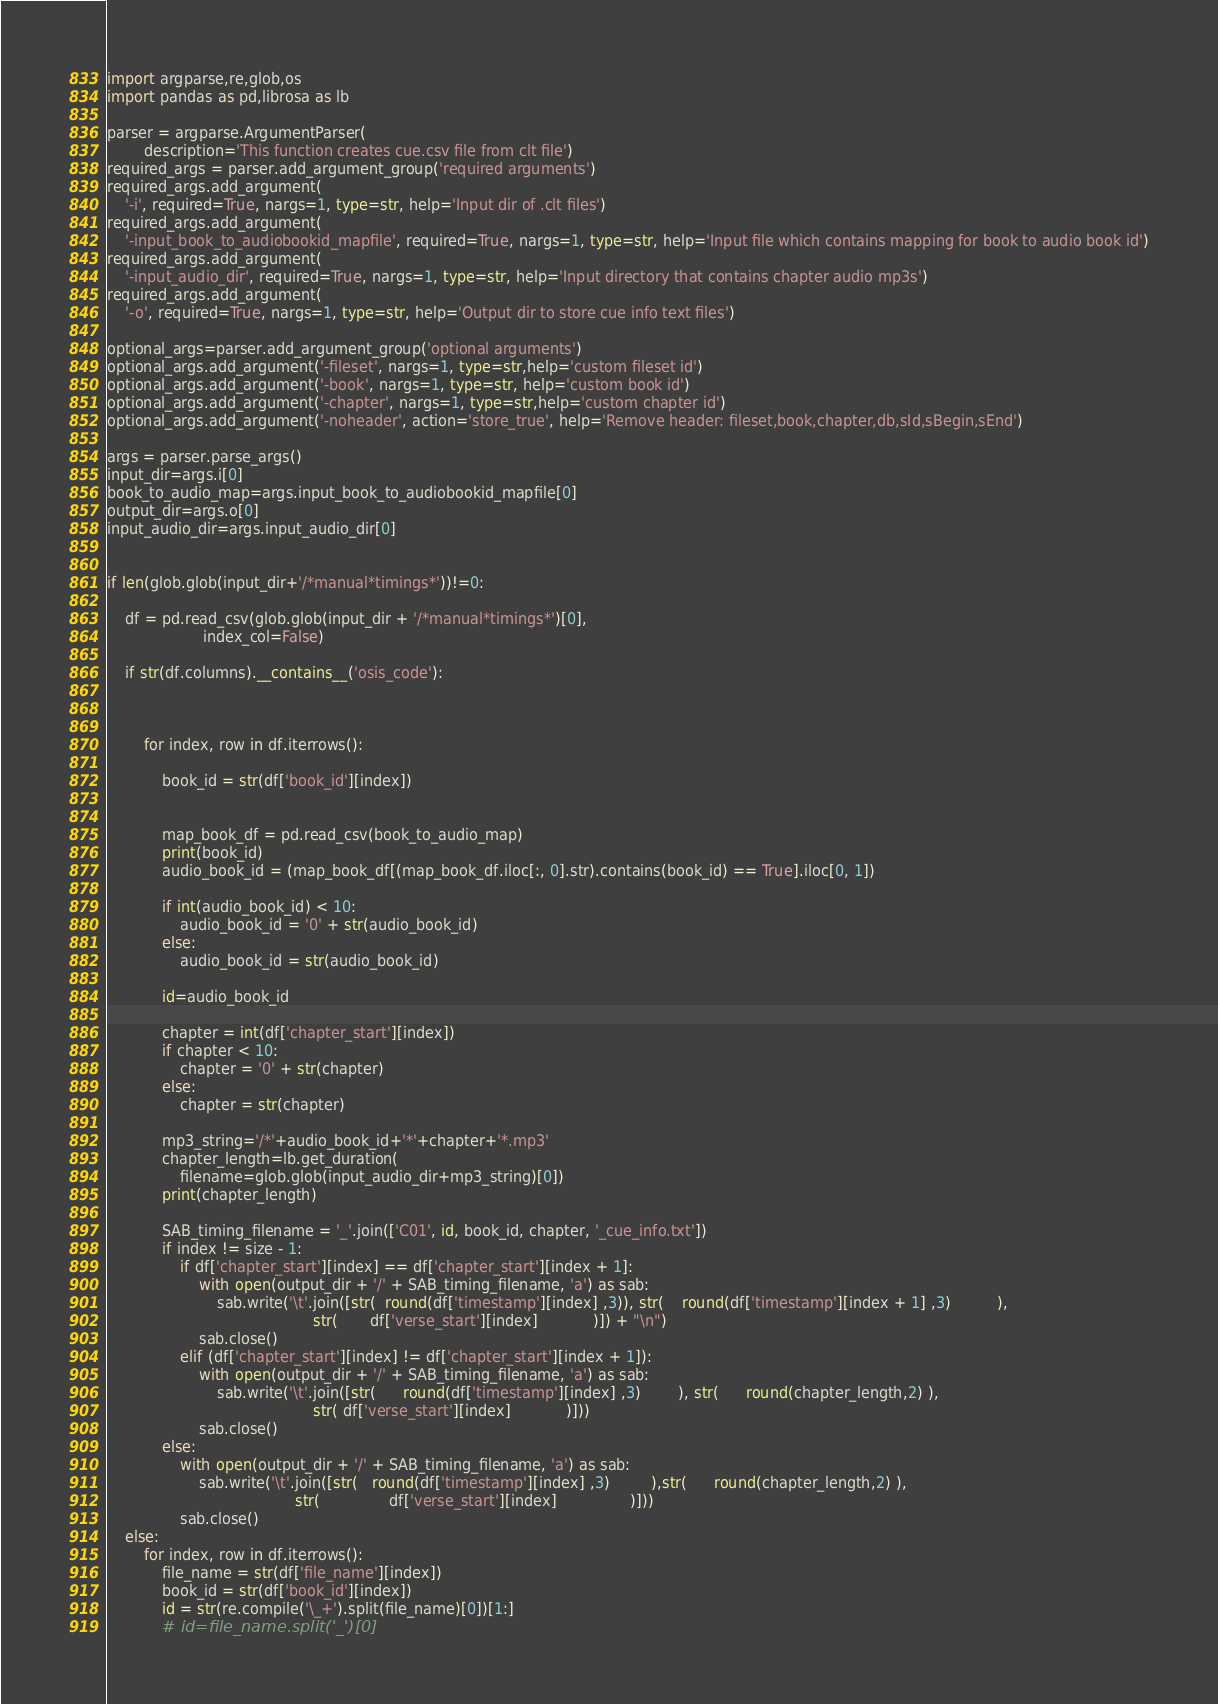<code> <loc_0><loc_0><loc_500><loc_500><_Python_>import argparse,re,glob,os
import pandas as pd,librosa as lb

parser = argparse.ArgumentParser(
        description='This function creates cue.csv file from clt file')
required_args = parser.add_argument_group('required arguments')
required_args.add_argument(
    '-i', required=True, nargs=1, type=str, help='Input dir of .clt files')
required_args.add_argument(
    '-input_book_to_audiobookid_mapfile', required=True, nargs=1, type=str, help='Input file which contains mapping for book to audio book id')
required_args.add_argument(
    '-input_audio_dir', required=True, nargs=1, type=str, help='Input directory that contains chapter audio mp3s')
required_args.add_argument(
    '-o', required=True, nargs=1, type=str, help='Output dir to store cue info text files')

optional_args=parser.add_argument_group('optional arguments')
optional_args.add_argument('-fileset', nargs=1, type=str,help='custom fileset id')
optional_args.add_argument('-book', nargs=1, type=str, help='custom book id')
optional_args.add_argument('-chapter', nargs=1, type=str,help='custom chapter id')
optional_args.add_argument('-noheader', action='store_true', help='Remove header: fileset,book,chapter,db,sId,sBegin,sEnd')

args = parser.parse_args()
input_dir=args.i[0]
book_to_audio_map=args.input_book_to_audiobookid_mapfile[0]
output_dir=args.o[0]
input_audio_dir=args.input_audio_dir[0]


if len(glob.glob(input_dir+'/*manual*timings*'))!=0:

    df = pd.read_csv(glob.glob(input_dir + '/*manual*timings*')[0],
                     index_col=False)

    if str(df.columns).__contains__('osis_code'):



        for index, row in df.iterrows():

            book_id = str(df['book_id'][index])


            map_book_df = pd.read_csv(book_to_audio_map)
            print(book_id)
            audio_book_id = (map_book_df[(map_book_df.iloc[:, 0].str).contains(book_id) == True].iloc[0, 1])

            if int(audio_book_id) < 10:
                audio_book_id = '0' + str(audio_book_id)
            else:
                audio_book_id = str(audio_book_id)

            id=audio_book_id

            chapter = int(df['chapter_start'][index])
            if chapter < 10:
                chapter = '0' + str(chapter)
            else:
                chapter = str(chapter)

            mp3_string='/*'+audio_book_id+'*'+chapter+'*.mp3'
            chapter_length=lb.get_duration(
                filename=glob.glob(input_audio_dir+mp3_string)[0])
            print(chapter_length)

            SAB_timing_filename = '_'.join(['C01', id, book_id, chapter, '_cue_info.txt'])
            if index != size - 1:
                if df['chapter_start'][index] == df['chapter_start'][index + 1]:
                    with open(output_dir + '/' + SAB_timing_filename, 'a') as sab:
                        sab.write('\t'.join([str(  round(df['timestamp'][index] ,3)), str(    round(df['timestamp'][index + 1] ,3)          ),
                                             str(       df['verse_start'][index]            )]) + "\n")
                    sab.close()
                elif (df['chapter_start'][index] != df['chapter_start'][index + 1]):
                    with open(output_dir + '/' + SAB_timing_filename, 'a') as sab:
                        sab.write('\t'.join([str(      round(df['timestamp'][index] ,3)        ), str(      round(chapter_length,2) ),
                                             str( df['verse_start'][index]            )]))
                    sab.close()
            else:
                with open(output_dir + '/' + SAB_timing_filename, 'a') as sab:
                    sab.write('\t'.join([str(   round(df['timestamp'][index] ,3)         ),str(      round(chapter_length,2) ),
                                         str(               df['verse_start'][index]                )]))
                sab.close()
    else:
        for index, row in df.iterrows():
            file_name = str(df['file_name'][index])
            book_id = str(df['book_id'][index])
            id = str(re.compile('\_+').split(file_name)[0])[1:]
            # id=file_name.split('_')[0]</code> 